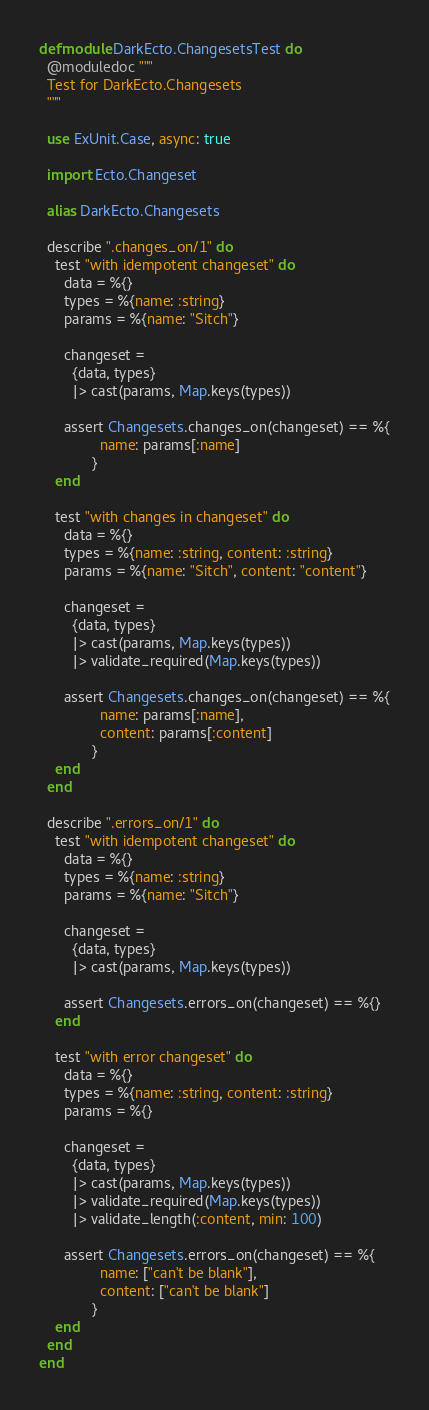Convert code to text. <code><loc_0><loc_0><loc_500><loc_500><_Elixir_>defmodule DarkEcto.ChangesetsTest do
  @moduledoc """
  Test for DarkEcto.Changesets
  """

  use ExUnit.Case, async: true

  import Ecto.Changeset

  alias DarkEcto.Changesets

  describe ".changes_on/1" do
    test "with idempotent changeset" do
      data = %{}
      types = %{name: :string}
      params = %{name: "Sitch"}

      changeset =
        {data, types}
        |> cast(params, Map.keys(types))

      assert Changesets.changes_on(changeset) == %{
               name: params[:name]
             }
    end

    test "with changes in changeset" do
      data = %{}
      types = %{name: :string, content: :string}
      params = %{name: "Sitch", content: "content"}

      changeset =
        {data, types}
        |> cast(params, Map.keys(types))
        |> validate_required(Map.keys(types))

      assert Changesets.changes_on(changeset) == %{
               name: params[:name],
               content: params[:content]
             }
    end
  end

  describe ".errors_on/1" do
    test "with idempotent changeset" do
      data = %{}
      types = %{name: :string}
      params = %{name: "Sitch"}

      changeset =
        {data, types}
        |> cast(params, Map.keys(types))

      assert Changesets.errors_on(changeset) == %{}
    end

    test "with error changeset" do
      data = %{}
      types = %{name: :string, content: :string}
      params = %{}

      changeset =
        {data, types}
        |> cast(params, Map.keys(types))
        |> validate_required(Map.keys(types))
        |> validate_length(:content, min: 100)

      assert Changesets.errors_on(changeset) == %{
               name: ["can't be blank"],
               content: ["can't be blank"]
             }
    end
  end
end
</code> 